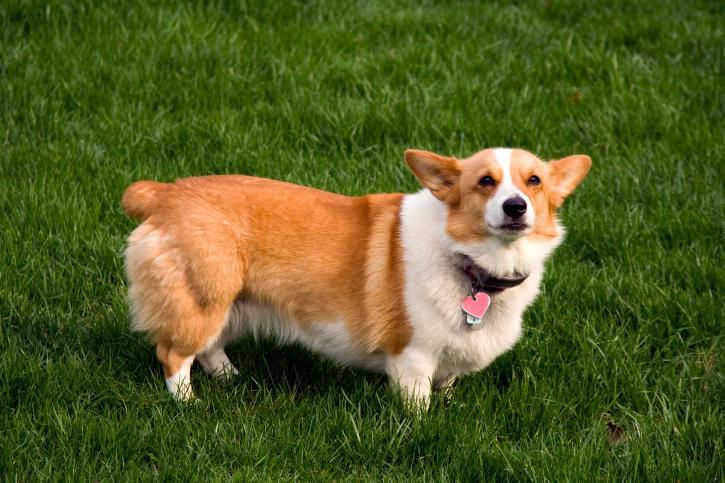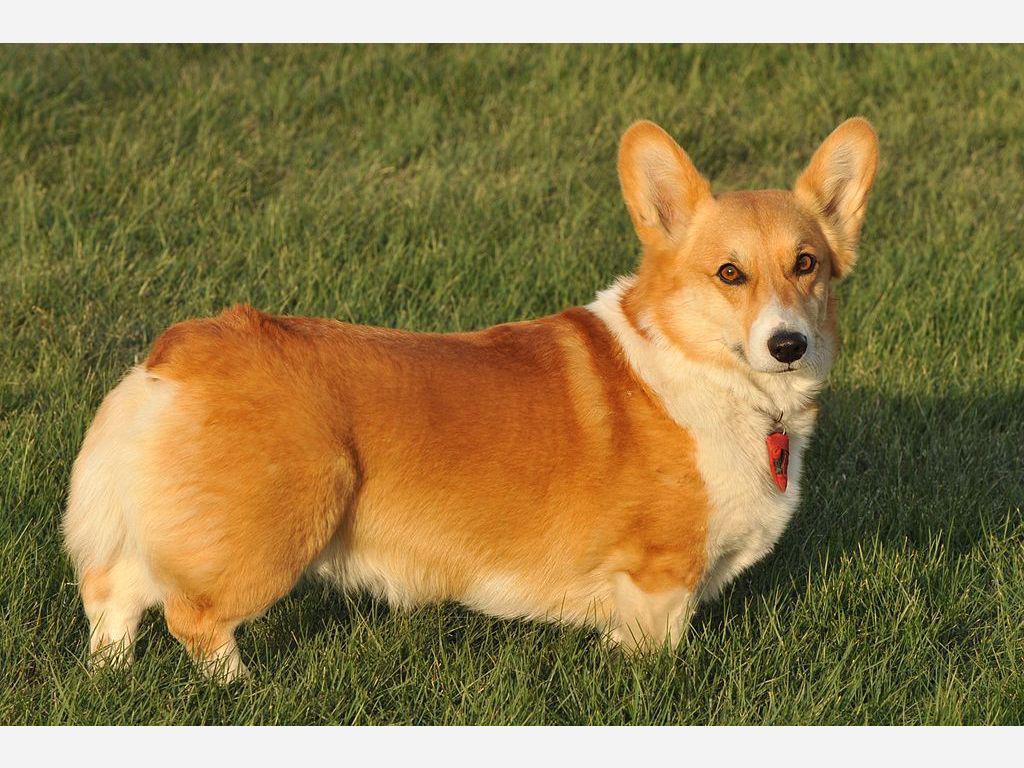The first image is the image on the left, the second image is the image on the right. For the images shown, is this caption "The dog in the image on the left is standing in the grass." true? Answer yes or no. Yes. The first image is the image on the left, the second image is the image on the right. Considering the images on both sides, is "Each image contains exactly one orange-and-white corgi, and at least one of the dogs pictured stands on all fours on green grass." valid? Answer yes or no. Yes. 